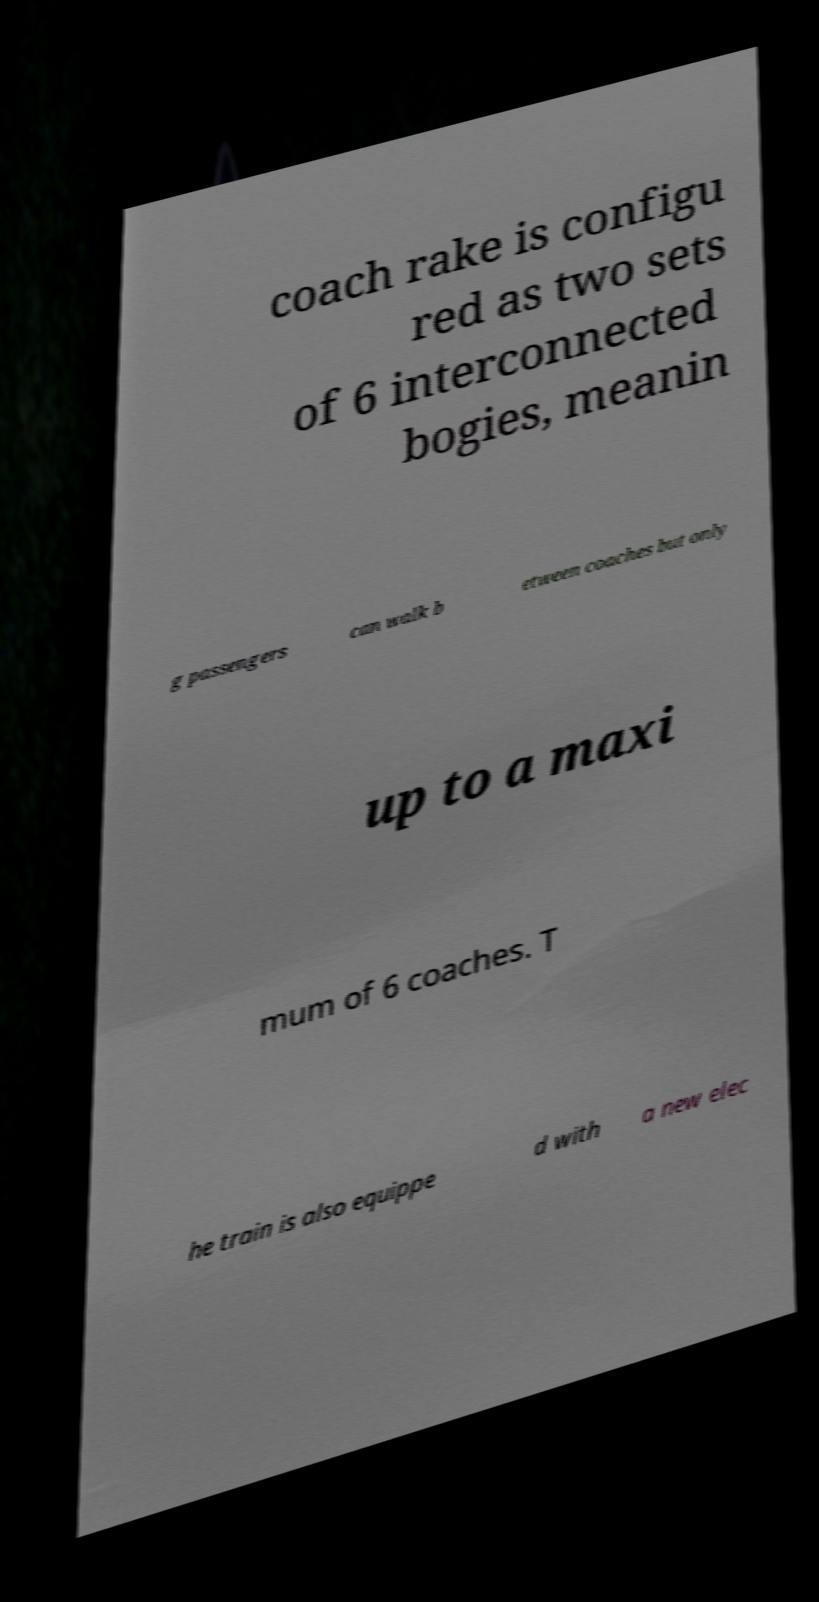Could you assist in decoding the text presented in this image and type it out clearly? coach rake is configu red as two sets of 6 interconnected bogies, meanin g passengers can walk b etween coaches but only up to a maxi mum of 6 coaches. T he train is also equippe d with a new elec 